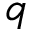<formula> <loc_0><loc_0><loc_500><loc_500>q</formula> 